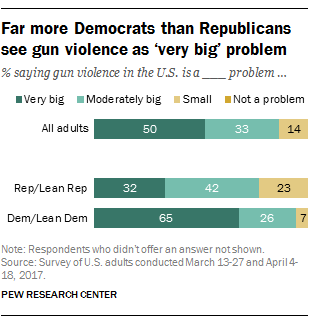Highlight a few significant elements in this photo. The smallest orange bar has a value of 7. The ratio of the two largest "moderately big" bars is 0.468055556... 